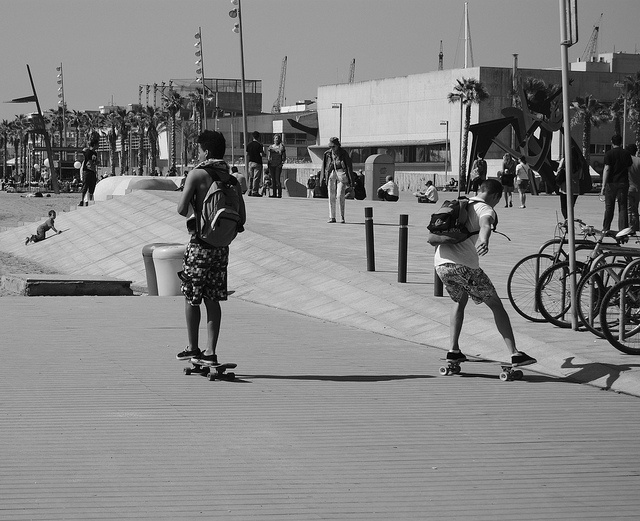Describe the objects in this image and their specific colors. I can see people in darkgray, black, gray, and lightgray tones, people in darkgray, black, gray, and gainsboro tones, bicycle in darkgray, black, gray, and lightgray tones, bicycle in darkgray, black, gray, and lightgray tones, and bicycle in darkgray, black, gray, and lightgray tones in this image. 